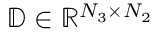Convert formula to latex. <formula><loc_0><loc_0><loc_500><loc_500>\mathbb { D } \in \mathbb { R } ^ { N _ { 3 } \times N _ { 2 } }</formula> 